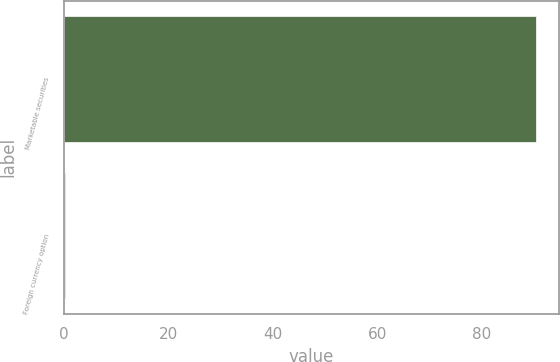Convert chart. <chart><loc_0><loc_0><loc_500><loc_500><bar_chart><fcel>Marketable securities<fcel>Foreign currency option<nl><fcel>90.31<fcel>0.2<nl></chart> 